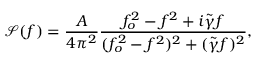Convert formula to latex. <formula><loc_0><loc_0><loc_500><loc_500>\mathcal { S } ( f ) = \frac { A } { 4 \pi ^ { 2 } } \frac { f _ { o } ^ { 2 } - f ^ { 2 } + i \tilde { \gamma } f } { ( f _ { o } ^ { 2 } - f ^ { 2 } ) ^ { 2 } + ( \tilde { \gamma } f ) ^ { 2 } } ,</formula> 